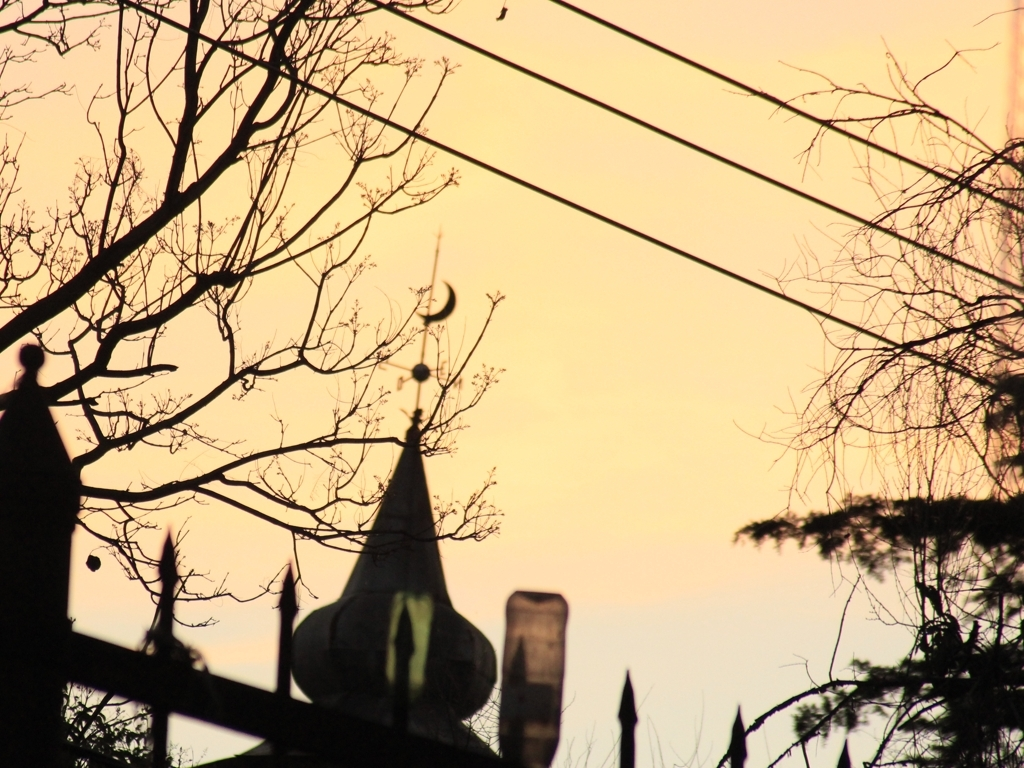What time of day does this image seem to capture, and what is the mood it conveys? This image captures the serene ambiance of twilight, where the sky transitions into a warm palette of colors as the sun sets. The mood seems tranquil and reflective, emphasized by the silhouettes of the trees and the emerging night lights. 